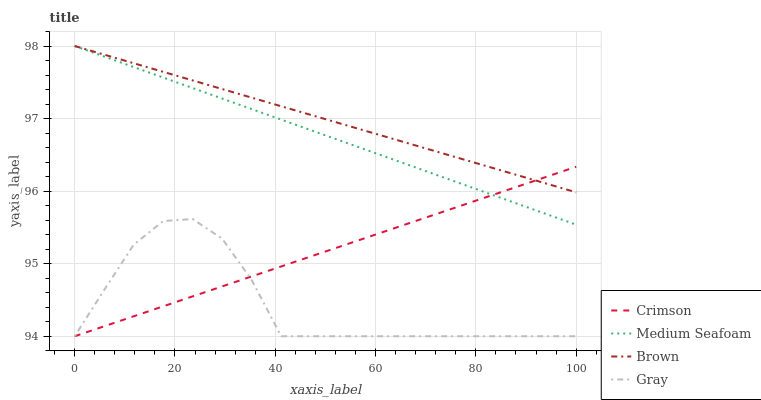Does Gray have the minimum area under the curve?
Answer yes or no. Yes. Does Brown have the maximum area under the curve?
Answer yes or no. Yes. Does Medium Seafoam have the minimum area under the curve?
Answer yes or no. No. Does Medium Seafoam have the maximum area under the curve?
Answer yes or no. No. Is Crimson the smoothest?
Answer yes or no. Yes. Is Gray the roughest?
Answer yes or no. Yes. Is Brown the smoothest?
Answer yes or no. No. Is Brown the roughest?
Answer yes or no. No. Does Medium Seafoam have the lowest value?
Answer yes or no. No. Does Medium Seafoam have the highest value?
Answer yes or no. Yes. Does Gray have the highest value?
Answer yes or no. No. Is Gray less than Brown?
Answer yes or no. Yes. Is Brown greater than Gray?
Answer yes or no. Yes. Does Medium Seafoam intersect Brown?
Answer yes or no. Yes. Is Medium Seafoam less than Brown?
Answer yes or no. No. Is Medium Seafoam greater than Brown?
Answer yes or no. No. Does Gray intersect Brown?
Answer yes or no. No. 